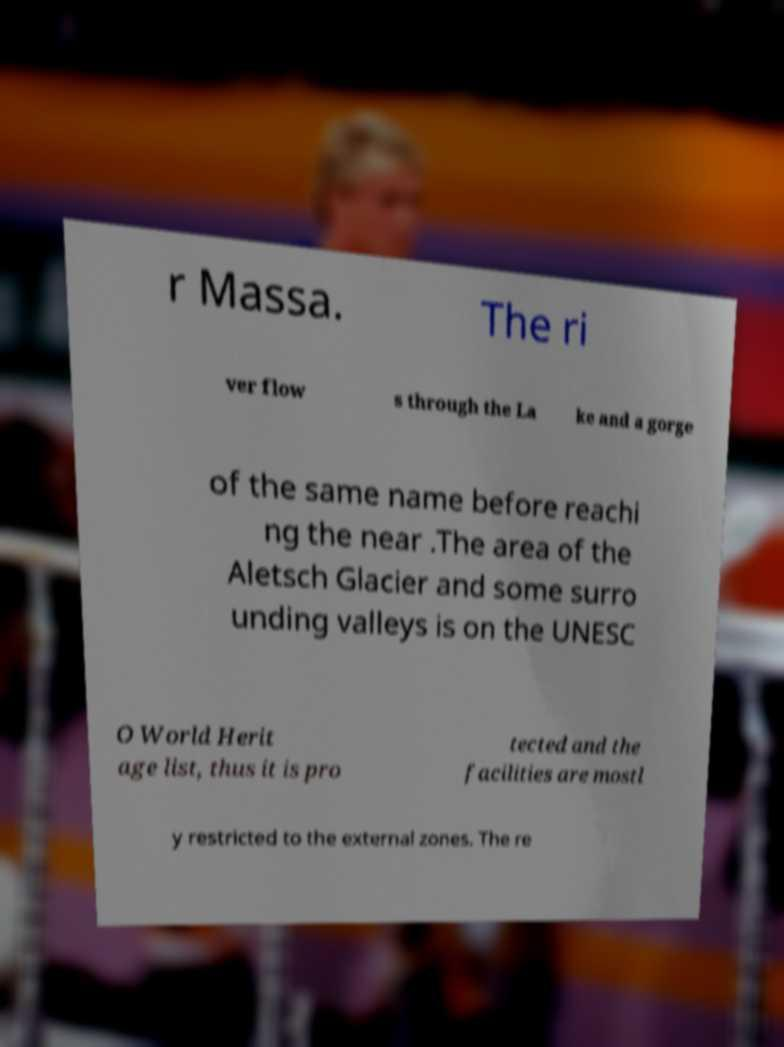Could you assist in decoding the text presented in this image and type it out clearly? r Massa. The ri ver flow s through the La ke and a gorge of the same name before reachi ng the near .The area of the Aletsch Glacier and some surro unding valleys is on the UNESC O World Herit age list, thus it is pro tected and the facilities are mostl y restricted to the external zones. The re 